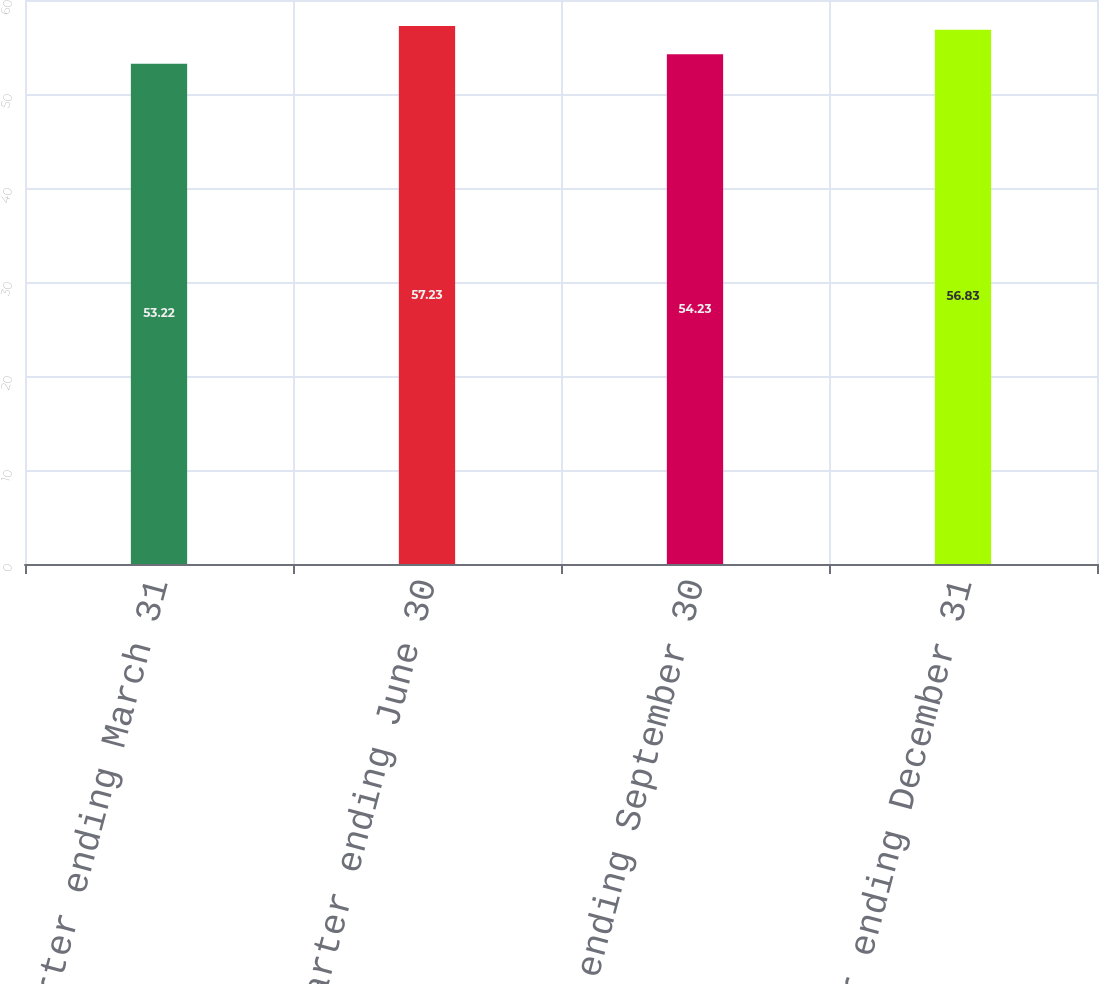Convert chart to OTSL. <chart><loc_0><loc_0><loc_500><loc_500><bar_chart><fcel>Quarter ending March 31<fcel>Quarter ending June 30<fcel>Quarter ending September 30<fcel>Quarter ending December 31<nl><fcel>53.22<fcel>57.23<fcel>54.23<fcel>56.83<nl></chart> 